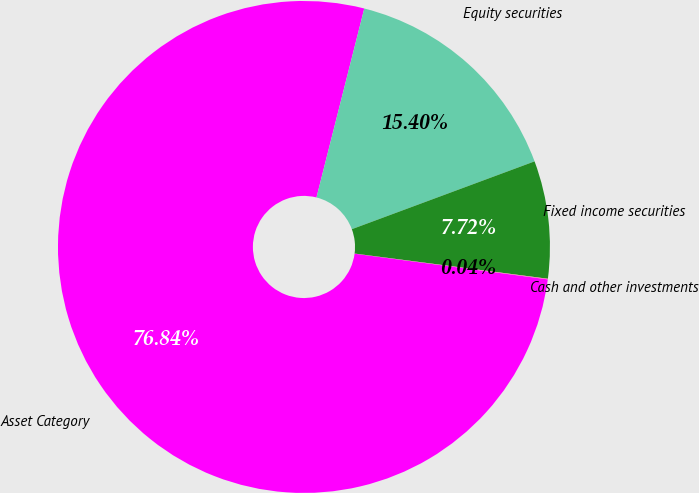<chart> <loc_0><loc_0><loc_500><loc_500><pie_chart><fcel>Asset Category<fcel>Equity securities<fcel>Fixed income securities<fcel>Cash and other investments<nl><fcel>76.84%<fcel>15.4%<fcel>7.72%<fcel>0.04%<nl></chart> 